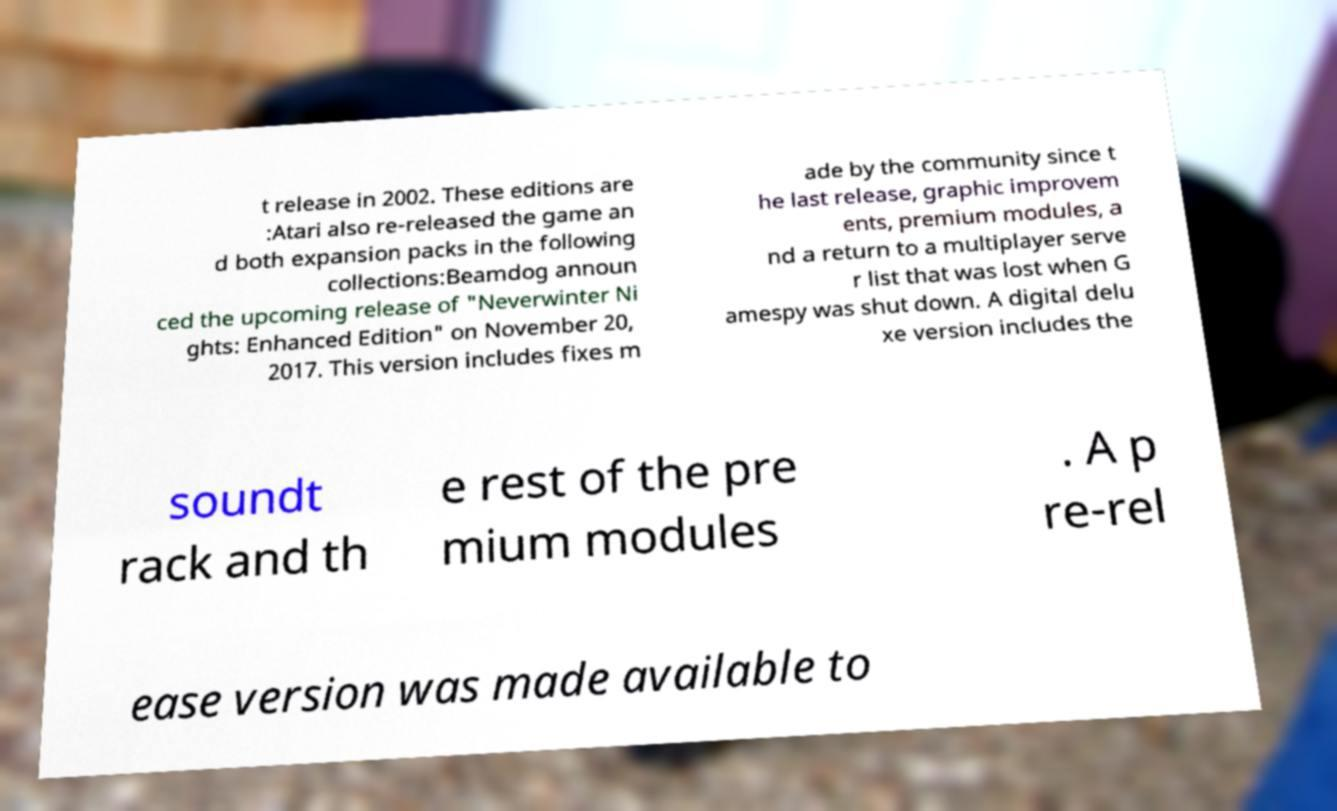I need the written content from this picture converted into text. Can you do that? t release in 2002. These editions are :Atari also re-released the game an d both expansion packs in the following collections:Beamdog announ ced the upcoming release of "Neverwinter Ni ghts: Enhanced Edition" on November 20, 2017. This version includes fixes m ade by the community since t he last release, graphic improvem ents, premium modules, a nd a return to a multiplayer serve r list that was lost when G amespy was shut down. A digital delu xe version includes the soundt rack and th e rest of the pre mium modules . A p re-rel ease version was made available to 